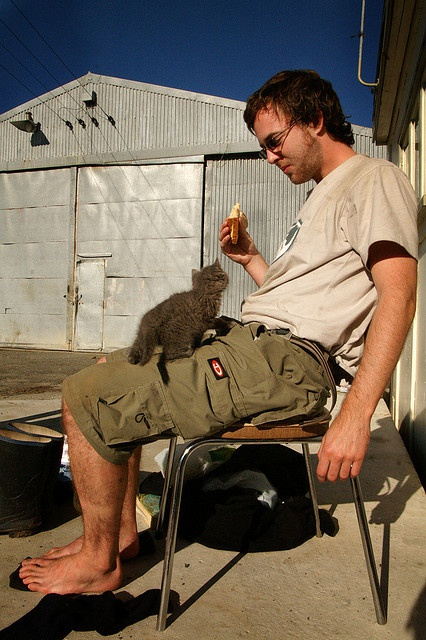Describe the objects in this image and their specific colors. I can see people in navy, gray, black, tan, and brown tones, backpack in navy, black, gray, and darkgreen tones, chair in navy, black, gray, and maroon tones, cat in navy, maroon, black, and darkgray tones, and sandwich in navy, brown, khaki, and maroon tones in this image. 